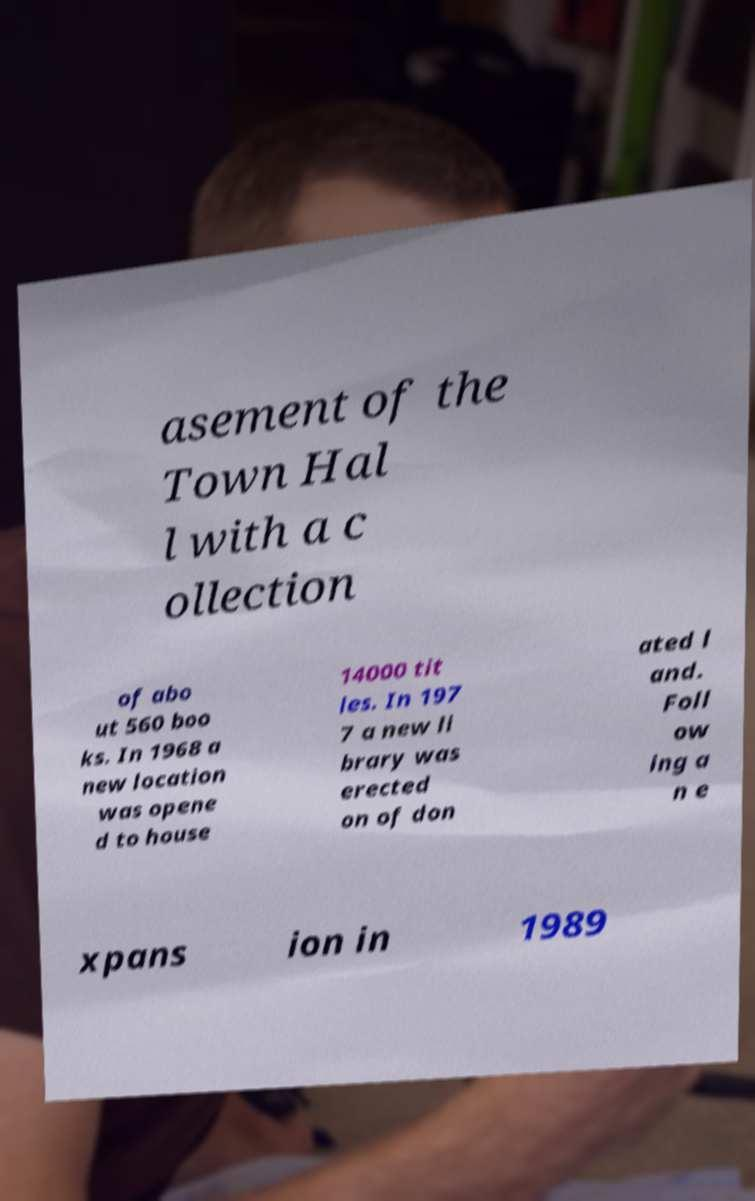Could you extract and type out the text from this image? asement of the Town Hal l with a c ollection of abo ut 560 boo ks. In 1968 a new location was opene d to house 14000 tit les. In 197 7 a new li brary was erected on of don ated l and. Foll ow ing a n e xpans ion in 1989 